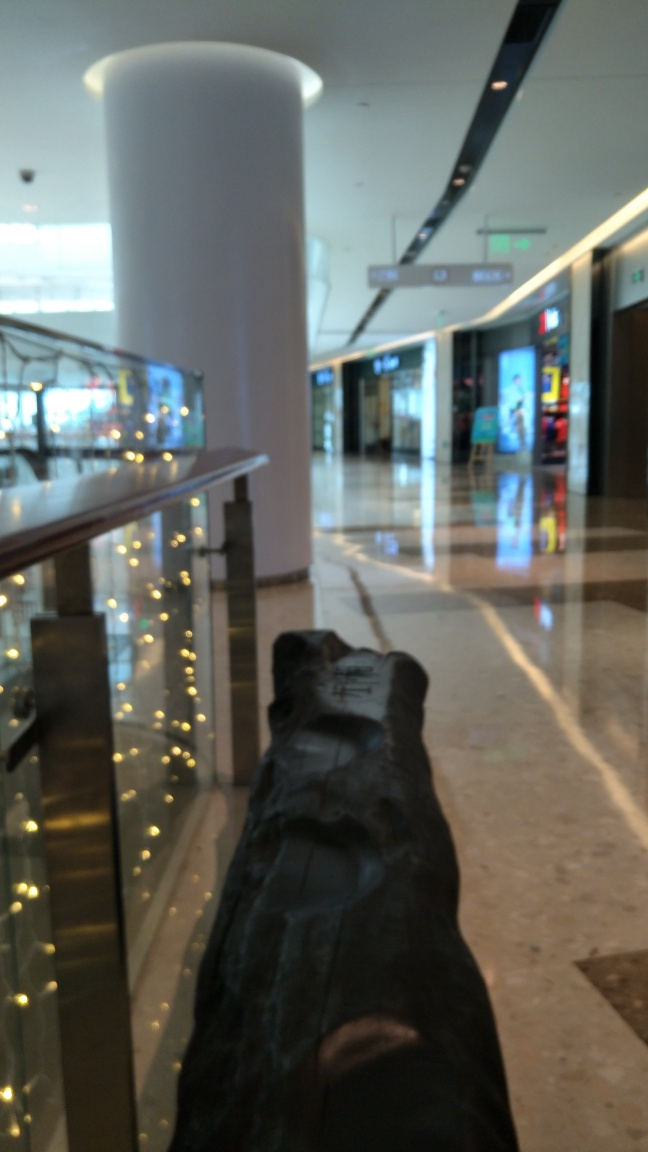What kind of place is depicted in the image? The image depicts an indoor setting, likely a modern shopping mall or a similar commercial space, characterized by its bright lighting, polished floors, and a mix of glass barriers alongside retail stores. Are there any notable architectural features or design elements visible? Notable architectural features include the sleek glass railings that add a contemporary feel, strategic lighting that provides ambiance, and the spacious design promoting an open and airy shopping experience. 